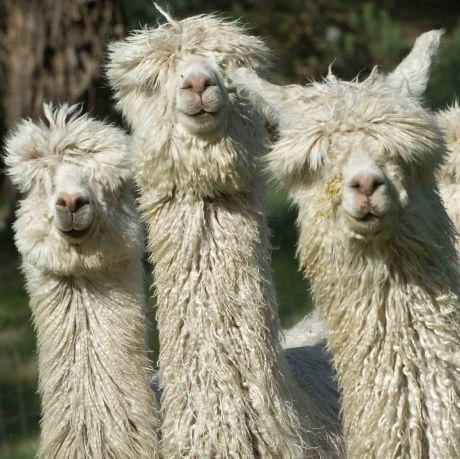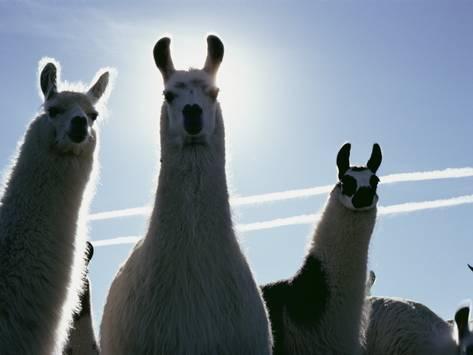The first image is the image on the left, the second image is the image on the right. Evaluate the accuracy of this statement regarding the images: "One image shows three forward-facing llamas with non-shaggy faces, and the other image contains three llamas with shaggy wool.". Is it true? Answer yes or no. Yes. 